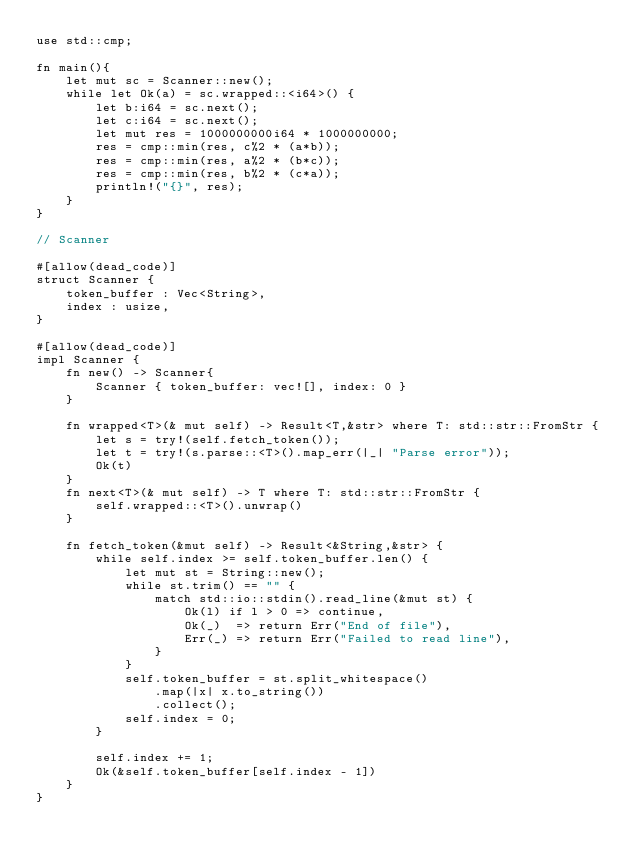<code> <loc_0><loc_0><loc_500><loc_500><_Rust_>use std::cmp;

fn main(){
    let mut sc = Scanner::new();
    while let Ok(a) = sc.wrapped::<i64>() {
        let b:i64 = sc.next();
        let c:i64 = sc.next();
        let mut res = 1000000000i64 * 1000000000;
        res = cmp::min(res, c%2 * (a*b));
        res = cmp::min(res, a%2 * (b*c));
        res = cmp::min(res, b%2 * (c*a));
        println!("{}", res);
    }
}

// Scanner

#[allow(dead_code)]
struct Scanner {
    token_buffer : Vec<String>,
    index : usize,
}

#[allow(dead_code)]
impl Scanner {
    fn new() -> Scanner{
        Scanner { token_buffer: vec![], index: 0 }
    }

    fn wrapped<T>(& mut self) -> Result<T,&str> where T: std::str::FromStr {
        let s = try!(self.fetch_token());
        let t = try!(s.parse::<T>().map_err(|_| "Parse error"));
        Ok(t)
    }
    fn next<T>(& mut self) -> T where T: std::str::FromStr {
        self.wrapped::<T>().unwrap()
    }

    fn fetch_token(&mut self) -> Result<&String,&str> {
        while self.index >= self.token_buffer.len() {
            let mut st = String::new();
            while st.trim() == "" {
                match std::io::stdin().read_line(&mut st) {
                    Ok(l) if l > 0 => continue,
                    Ok(_)  => return Err("End of file"),
                    Err(_) => return Err("Failed to read line"),
                }
            }
            self.token_buffer = st.split_whitespace()
                .map(|x| x.to_string())
                .collect();
            self.index = 0;
        }

        self.index += 1;
        Ok(&self.token_buffer[self.index - 1])
    }
}
</code> 